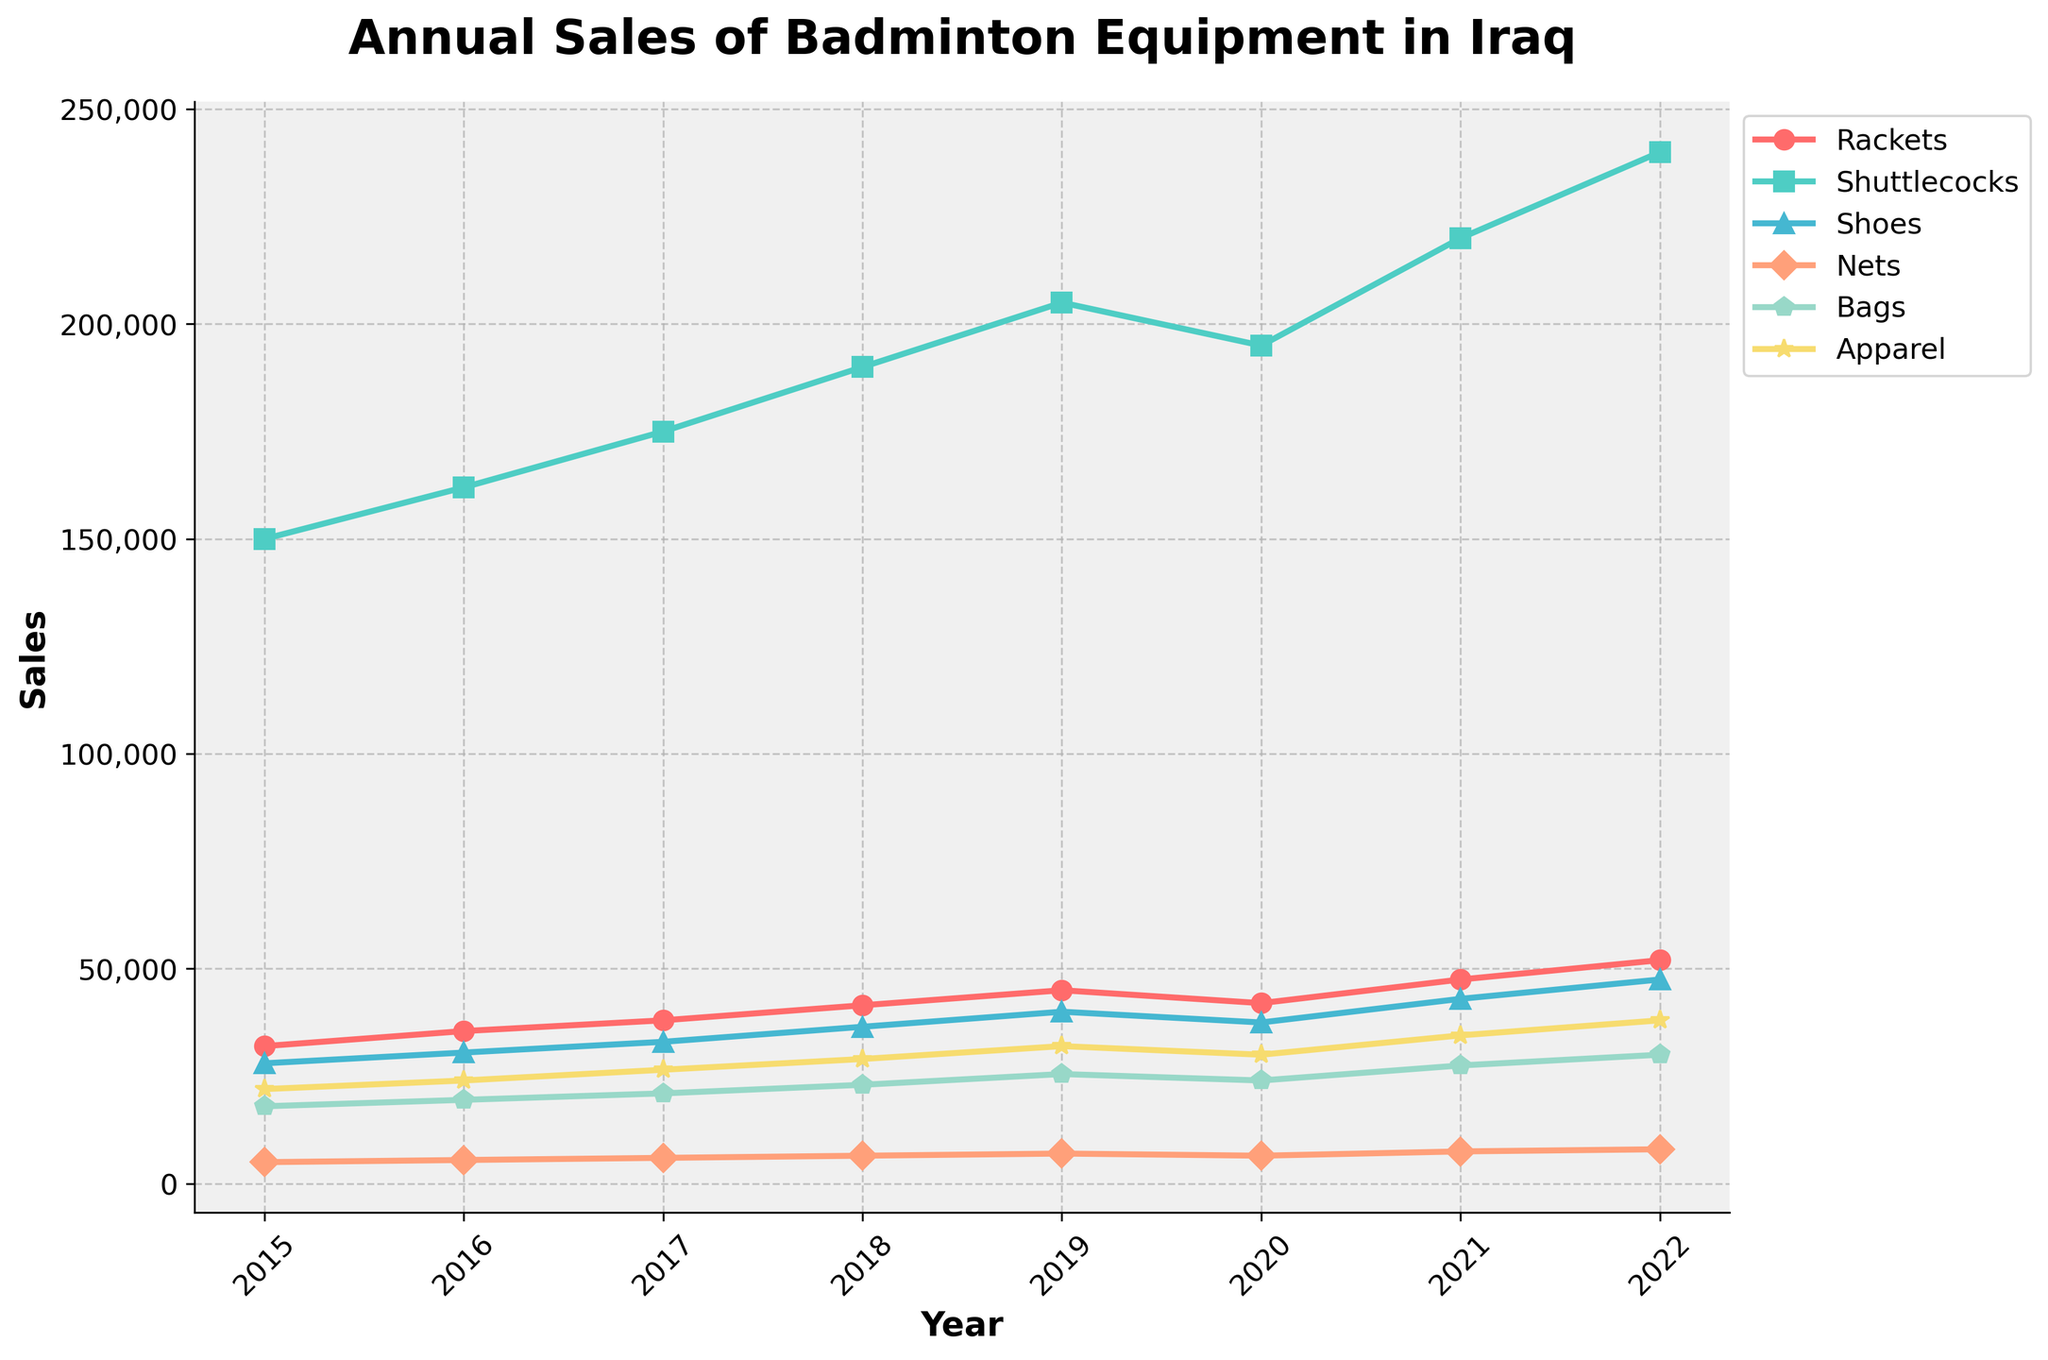What is the total sales for 2021 combining all product types? Sum the sales figures for each product type in 2021: 47500 (Rackets) + 220000 (Shuttlecocks) + 43000 (Shoes) + 7500 (Nets) + 27500 (Bags) + 34500 (Apparel) = 380000
Answer: 380000 Which product type had the highest sales in 2020? Look at the 2020 data and compare sales figures for each product type. Shuttlecocks had the highest sales with 195000.
Answer: Shuttlecocks By how much did racket sales increase from 2015 to 2022? Subtract the 2015 racket sales from the 2022 racket sales: 52000 - 32000 = 20000
Answer: 20000 What was the average annual sales of shoes from 2015 to 2022? Sum the annual shoe sales from 2015 to 2022 and divide by the number of years: (28000 + 30500 + 33000 + 36500 + 40000 + 37500 + 43000 + 47500) / 8 = 37125
Answer: 37125 Which year did bags have their highest sales, and what were the sales? Check the sales figures for bags each year and identify the highest: 2022 with 30000.
Answer: 2022, 30000 Which product type had the least growth in sales from 2015 to 2022? Calculate the difference in sales from 2015 to 2022 for each product type and compare: Nets increased from 5000 to 8000, which is the smallest growth.
Answer: Nets How much did apparel sales change from 2019 to 2020? Subtract the 2019 apparel sales from the 2020 apparel sales: 30000 - 32000 = -2000
Answer: -2000 Which product type saw the largest percent increase in sales from 2015 to 2022? Calculate the percent increase for each product type from 2015 to 2022 and compare: ((52000-32000)/32000) * 100 for rackets, (240000-150000)/150000 * 100 for shuttlecocks, etc. Shuttlecocks had the largest percent increase: ((240000-150000)/150000) * 100 = 60%
Answer: Shuttlecocks, 60% What is the combined total sales of Nets and Bags in 2017? Add the sales of Nets and Bags in 2017: 6000 + 21000 = 27000
Answer: 27000 What trend do you observe for shuttlecock sales over the years? Observe the trend from the figure; Shuttlecock sales steadily increased each year from 2015 to 2022.
Answer: Steady increase 